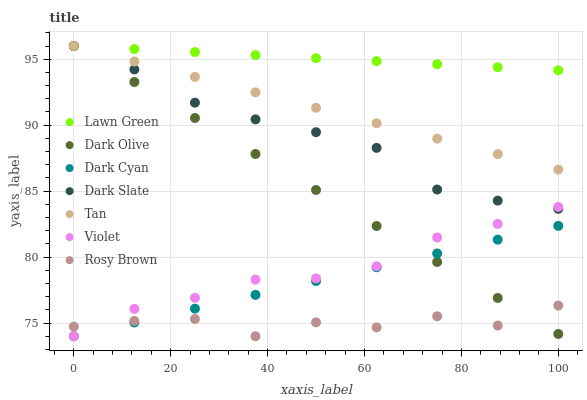Does Rosy Brown have the minimum area under the curve?
Answer yes or no. Yes. Does Lawn Green have the maximum area under the curve?
Answer yes or no. Yes. Does Dark Olive have the minimum area under the curve?
Answer yes or no. No. Does Dark Olive have the maximum area under the curve?
Answer yes or no. No. Is Dark Cyan the smoothest?
Answer yes or no. Yes. Is Rosy Brown the roughest?
Answer yes or no. Yes. Is Dark Olive the smoothest?
Answer yes or no. No. Is Dark Olive the roughest?
Answer yes or no. No. Does Rosy Brown have the lowest value?
Answer yes or no. Yes. Does Dark Olive have the lowest value?
Answer yes or no. No. Does Tan have the highest value?
Answer yes or no. Yes. Does Rosy Brown have the highest value?
Answer yes or no. No. Is Rosy Brown less than Lawn Green?
Answer yes or no. Yes. Is Lawn Green greater than Rosy Brown?
Answer yes or no. Yes. Does Dark Olive intersect Violet?
Answer yes or no. Yes. Is Dark Olive less than Violet?
Answer yes or no. No. Is Dark Olive greater than Violet?
Answer yes or no. No. Does Rosy Brown intersect Lawn Green?
Answer yes or no. No. 